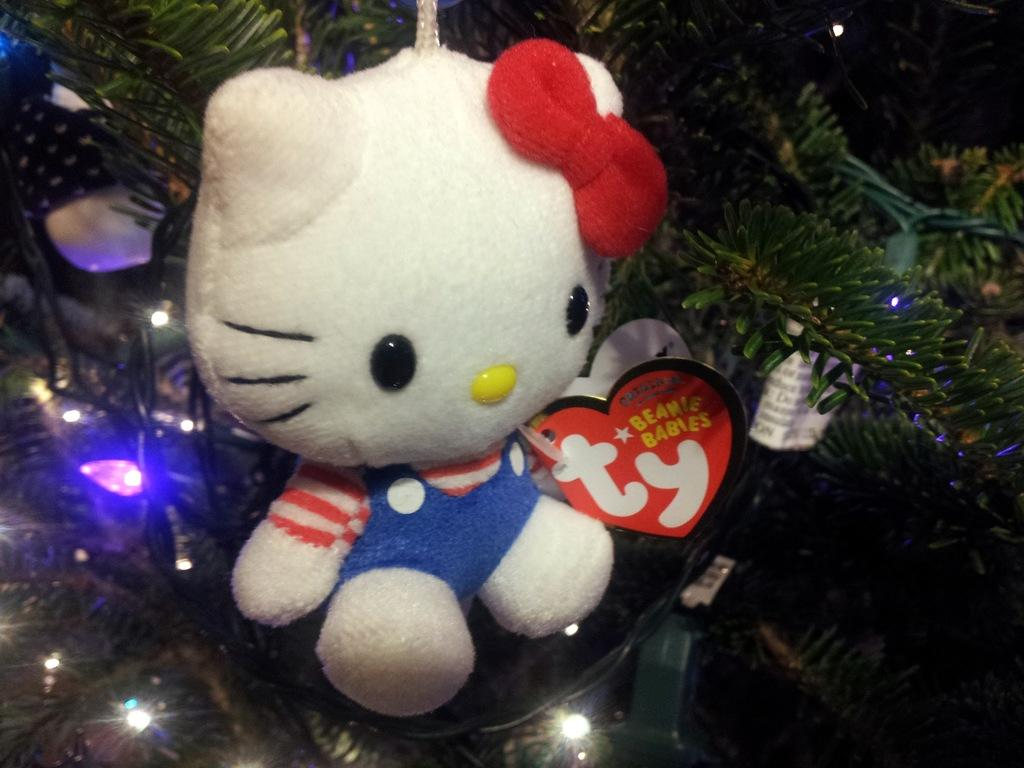What type of tree is present in the image? There is an xmas tree in the image. What feature of the xmas tree is mentioned in the facts? The xmas tree has decorative lights. What other object is mentioned in the image? There is a doll in the image. What type of clouds can be seen in the image? There are no clouds present in the image. What type of art is displayed on the xmas tree? The facts do not mention any art displayed on the xmas tree. 